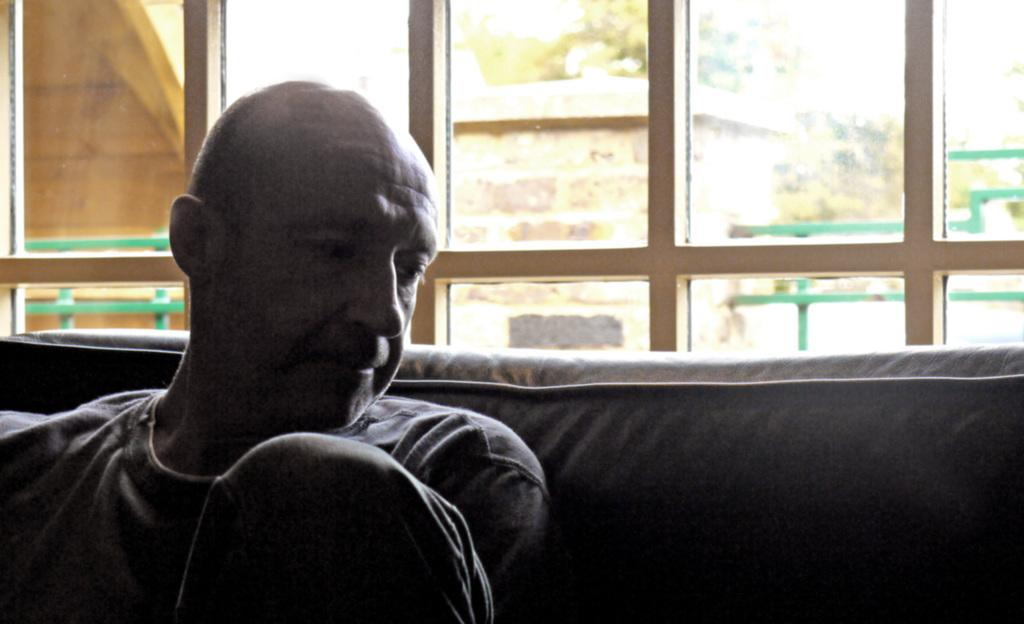What is present in the image? There is a person in the image. What can be seen on the walls in the image? There are windows in the image. What is visible through the windows? A wall and trees are visible through the windows. What type of zinc is being smashed by the person in the image? There is no zinc or smashing activity present in the image. 